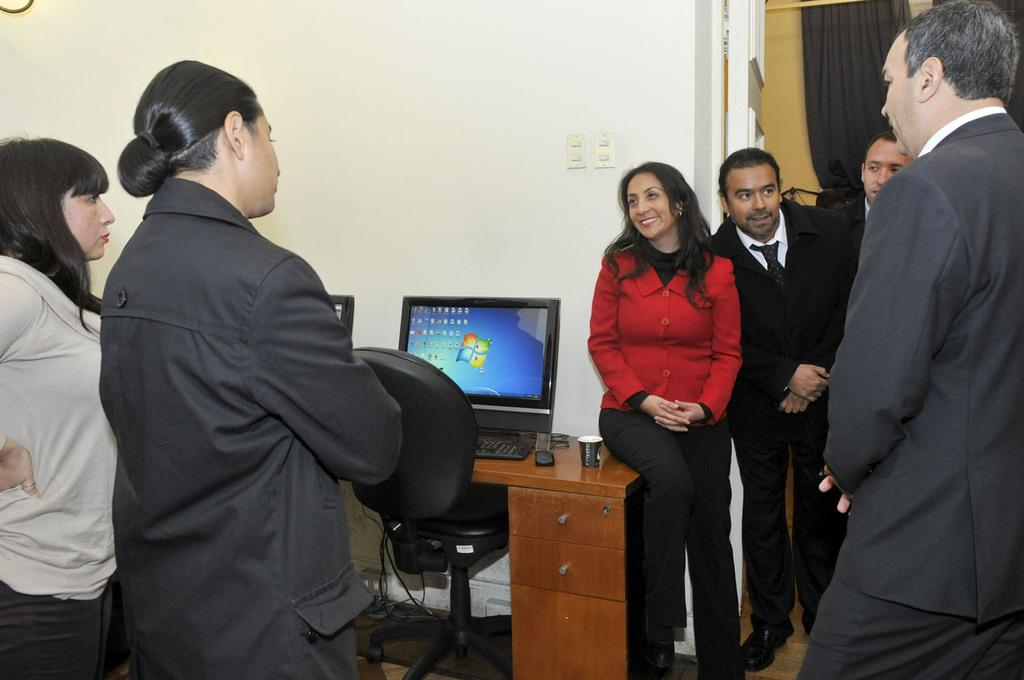What can be seen in the image involving people? There are people standing in the image. What piece of furniture is present in the image? There is a desk in the image. What electronic devices are on the desk? There is a monitor, keyboard, and mouse on the desk. What is the seating arrangement in the image? There is a chair in the image. What type of background is visible in the image? There is a wall in the image. Is there a slope visible in the image? There is no slope present in the image. Can you tell me the birth date of the person standing in the image? The image does not provide any information about the birth date of the person standing in the image. 